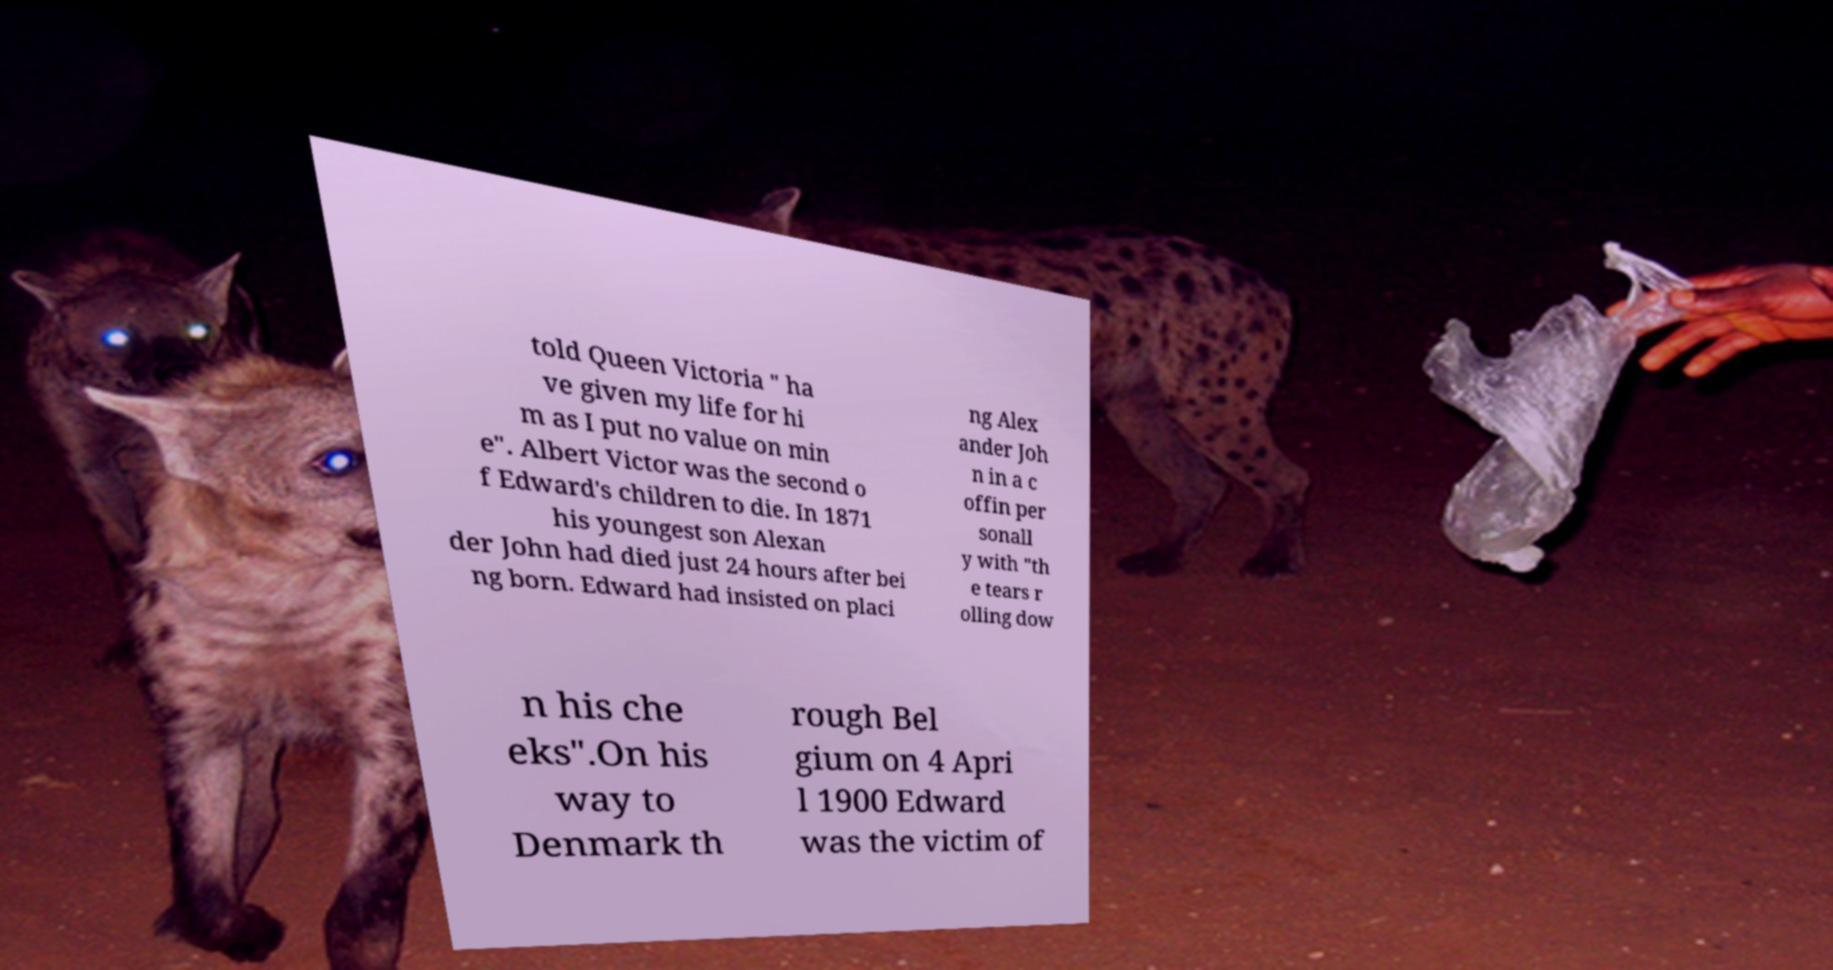Could you assist in decoding the text presented in this image and type it out clearly? told Queen Victoria " ha ve given my life for hi m as I put no value on min e". Albert Victor was the second o f Edward's children to die. In 1871 his youngest son Alexan der John had died just 24 hours after bei ng born. Edward had insisted on placi ng Alex ander Joh n in a c offin per sonall y with "th e tears r olling dow n his che eks".On his way to Denmark th rough Bel gium on 4 Apri l 1900 Edward was the victim of 